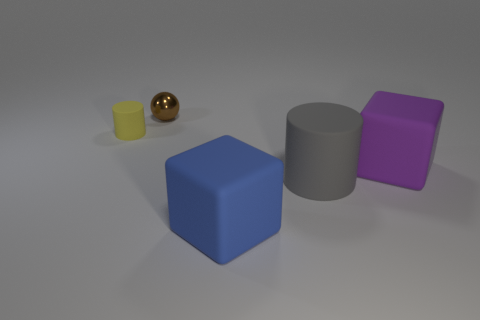Subtract 0 gray cubes. How many objects are left? 5 Subtract all spheres. How many objects are left? 4 Subtract 1 cylinders. How many cylinders are left? 1 Subtract all red balls. Subtract all purple blocks. How many balls are left? 1 Subtract all yellow cylinders. How many cyan balls are left? 0 Subtract all big cyan rubber balls. Subtract all gray matte cylinders. How many objects are left? 4 Add 4 large matte cubes. How many large matte cubes are left? 6 Add 2 big brown cylinders. How many big brown cylinders exist? 2 Add 4 small balls. How many objects exist? 9 